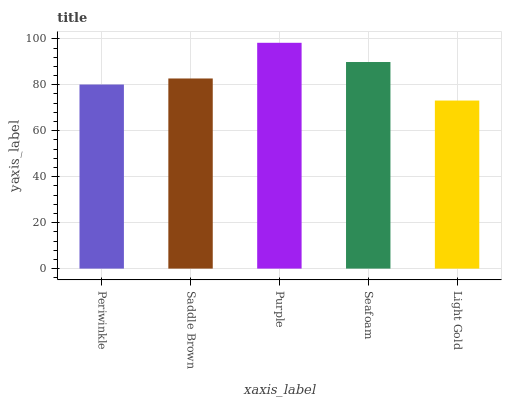Is Light Gold the minimum?
Answer yes or no. Yes. Is Purple the maximum?
Answer yes or no. Yes. Is Saddle Brown the minimum?
Answer yes or no. No. Is Saddle Brown the maximum?
Answer yes or no. No. Is Saddle Brown greater than Periwinkle?
Answer yes or no. Yes. Is Periwinkle less than Saddle Brown?
Answer yes or no. Yes. Is Periwinkle greater than Saddle Brown?
Answer yes or no. No. Is Saddle Brown less than Periwinkle?
Answer yes or no. No. Is Saddle Brown the high median?
Answer yes or no. Yes. Is Saddle Brown the low median?
Answer yes or no. Yes. Is Seafoam the high median?
Answer yes or no. No. Is Seafoam the low median?
Answer yes or no. No. 